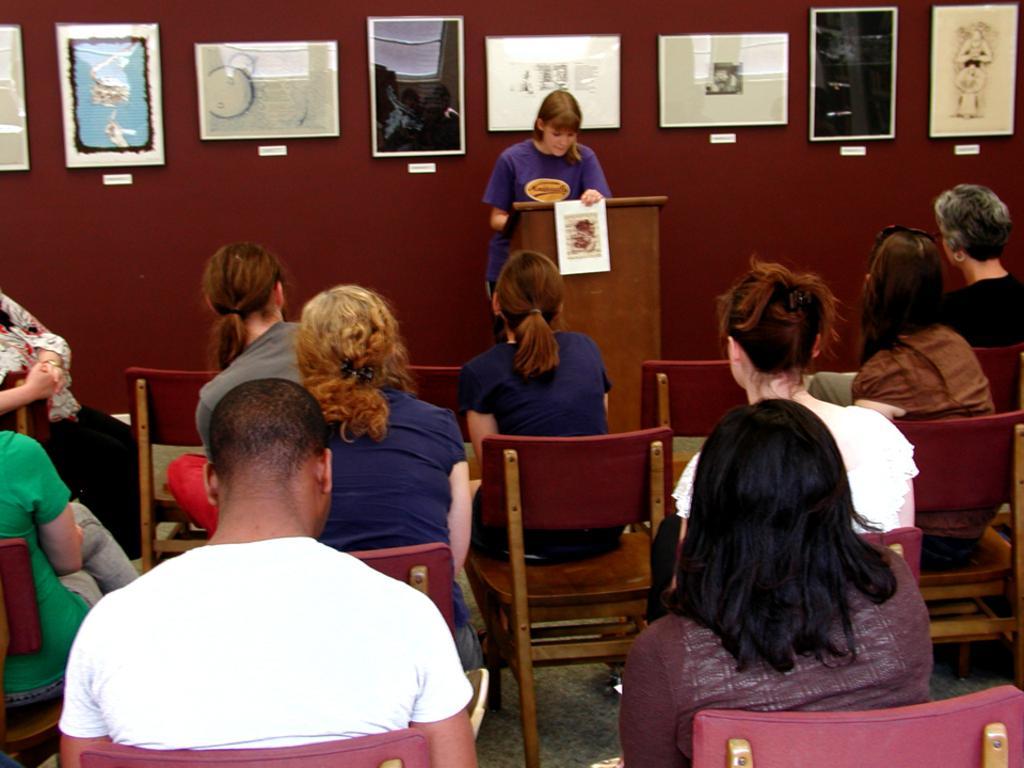What are the people in the image doing? There is a group of people sitting on chairs in the image. Can you describe the woman in the image? There is a woman standing in the image. What is the woman standing near? There is a podium in front of the woman. What can be seen on the wall in the background of the image? There are frames attached to a wall in the background of the image. Can you see the ocean in the background of the image? No, there is no ocean visible in the image. What type of pickle is the woman holding in the image? There is no pickle present in the image. 